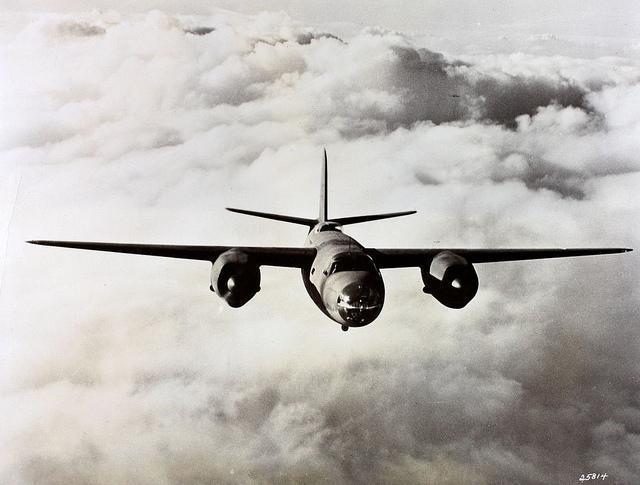How many airplanes are there?
Give a very brief answer. 1. How many motorcycles can be seen?
Give a very brief answer. 0. 